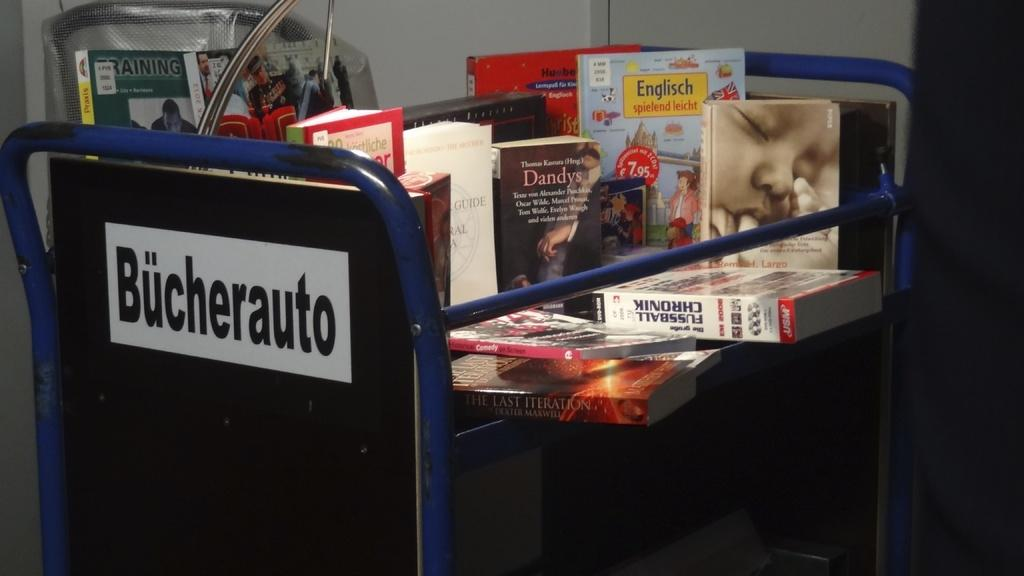Provide a one-sentence caption for the provided image. A library cart filled with different titled books with the word Bucherauto on the blue cart. 